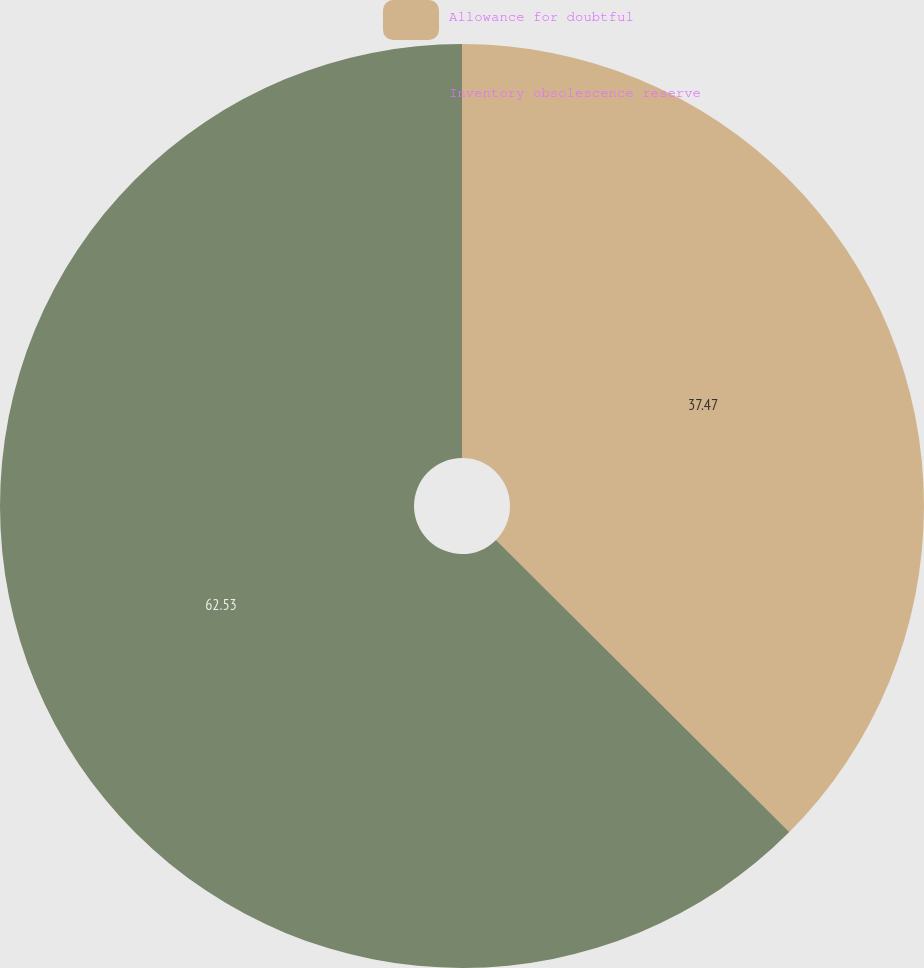Convert chart. <chart><loc_0><loc_0><loc_500><loc_500><pie_chart><fcel>Allowance for doubtful<fcel>Inventory obsolescence reserve<nl><fcel>37.47%<fcel>62.53%<nl></chart> 